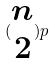<formula> <loc_0><loc_0><loc_500><loc_500>( \begin{matrix} n \\ 2 \end{matrix} ) p</formula> 